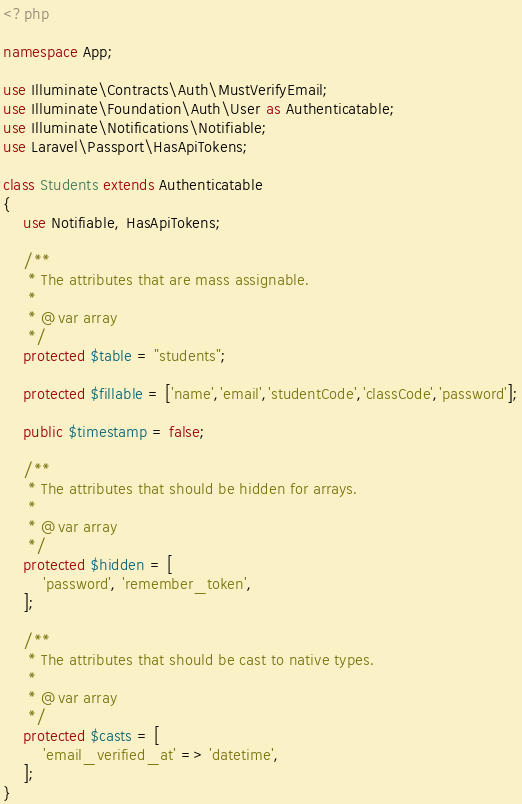Convert code to text. <code><loc_0><loc_0><loc_500><loc_500><_PHP_><?php

namespace App;

use Illuminate\Contracts\Auth\MustVerifyEmail;
use Illuminate\Foundation\Auth\User as Authenticatable;
use Illuminate\Notifications\Notifiable;
use Laravel\Passport\HasApiTokens;

class Students extends Authenticatable
{
    use Notifiable, HasApiTokens;

    /**
     * The attributes that are mass assignable.
     *
     * @var array
     */
    protected $table = "students";

    protected $fillable = ['name','email','studentCode','classCode','password'];

    public $timestamp = false;

    /**
     * The attributes that should be hidden for arrays.
     *
     * @var array
     */
    protected $hidden = [
        'password', 'remember_token',
    ];

    /**
     * The attributes that should be cast to native types.
     *
     * @var array
     */
    protected $casts = [
        'email_verified_at' => 'datetime',
    ];
}
</code> 